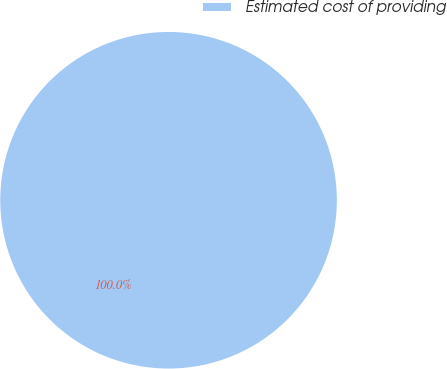Convert chart to OTSL. <chart><loc_0><loc_0><loc_500><loc_500><pie_chart><fcel>Estimated cost of providing<nl><fcel>100.0%<nl></chart> 